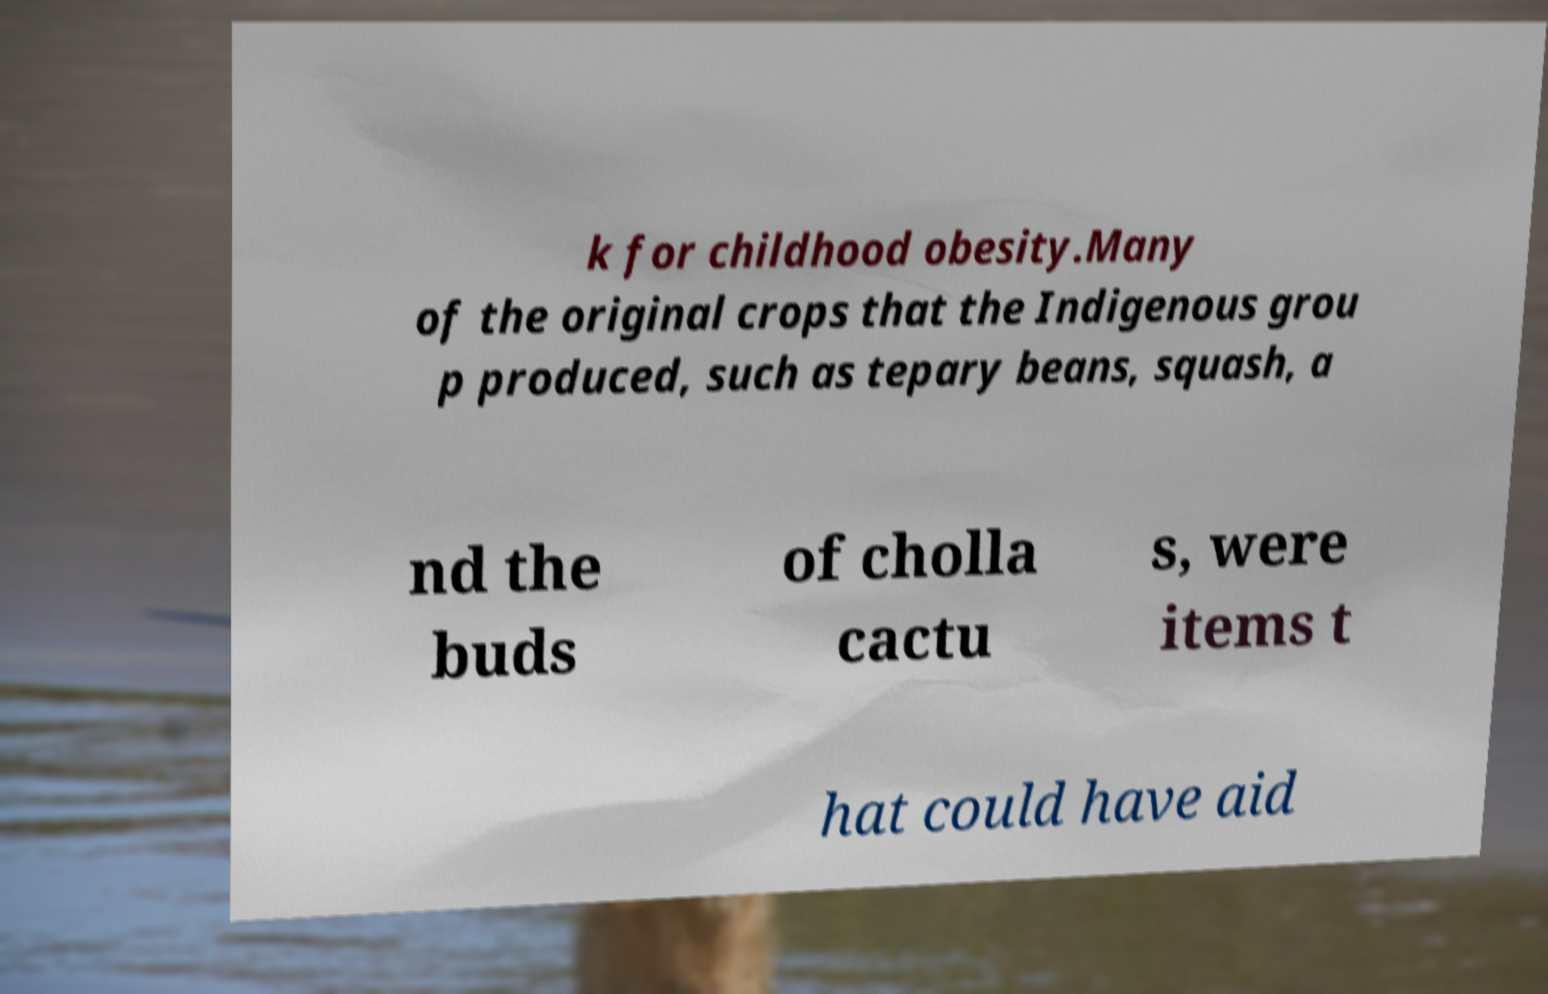Can you accurately transcribe the text from the provided image for me? k for childhood obesity.Many of the original crops that the Indigenous grou p produced, such as tepary beans, squash, a nd the buds of cholla cactu s, were items t hat could have aid 